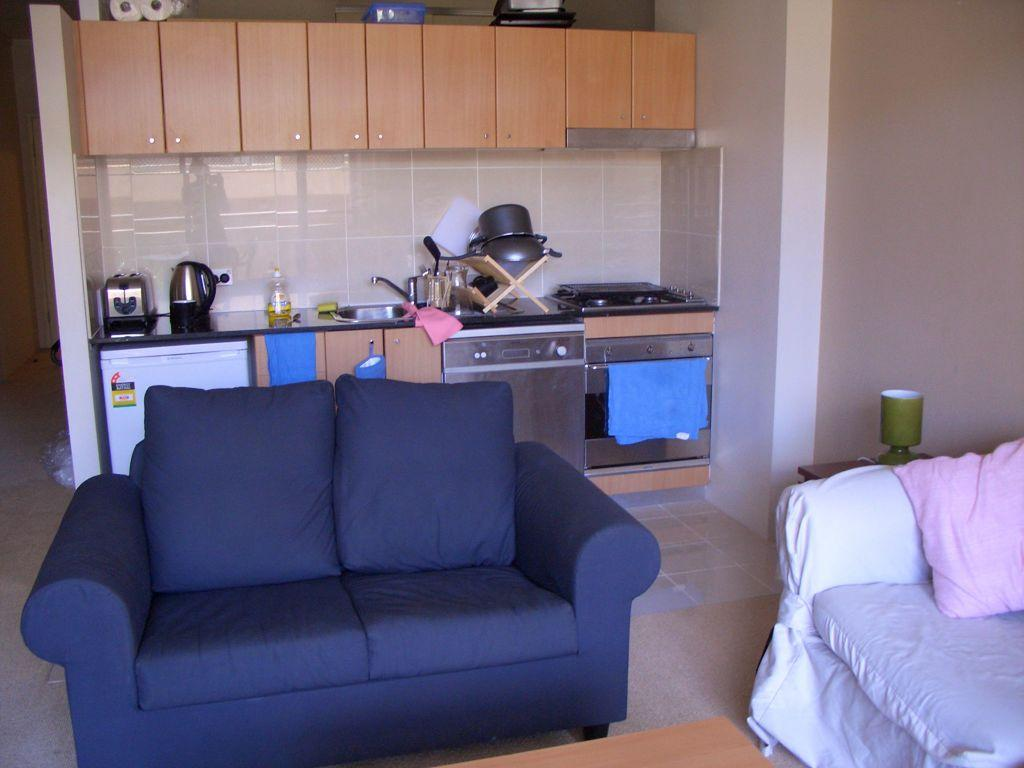What type of furniture is present in the image? There is a sofa and a chair in the image. What type of storage units can be seen in the image? There are cupboards in the image. What items related to the kitchen can be seen in the image? Kitchen property items are present in the image. What type of lighting is present in the image? There is a lamp in the image. What type of structure is visible in the background of the image? There is a wall in the image. What color is the mitten that the parent is wearing in the image? There is no mitten or parent present in the image; the facts provided do not mention any people or clothing items. 